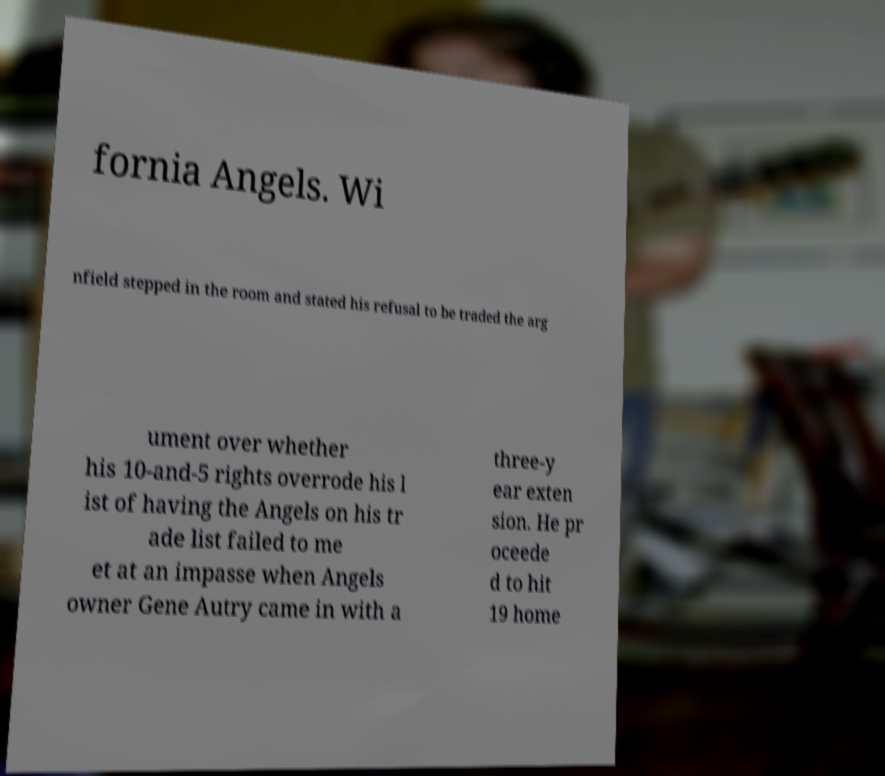Please identify and transcribe the text found in this image. fornia Angels. Wi nfield stepped in the room and stated his refusal to be traded the arg ument over whether his 10-and-5 rights overrode his l ist of having the Angels on his tr ade list failed to me et at an impasse when Angels owner Gene Autry came in with a three-y ear exten sion. He pr oceede d to hit 19 home 